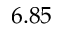<formula> <loc_0><loc_0><loc_500><loc_500>6 . 8 5</formula> 